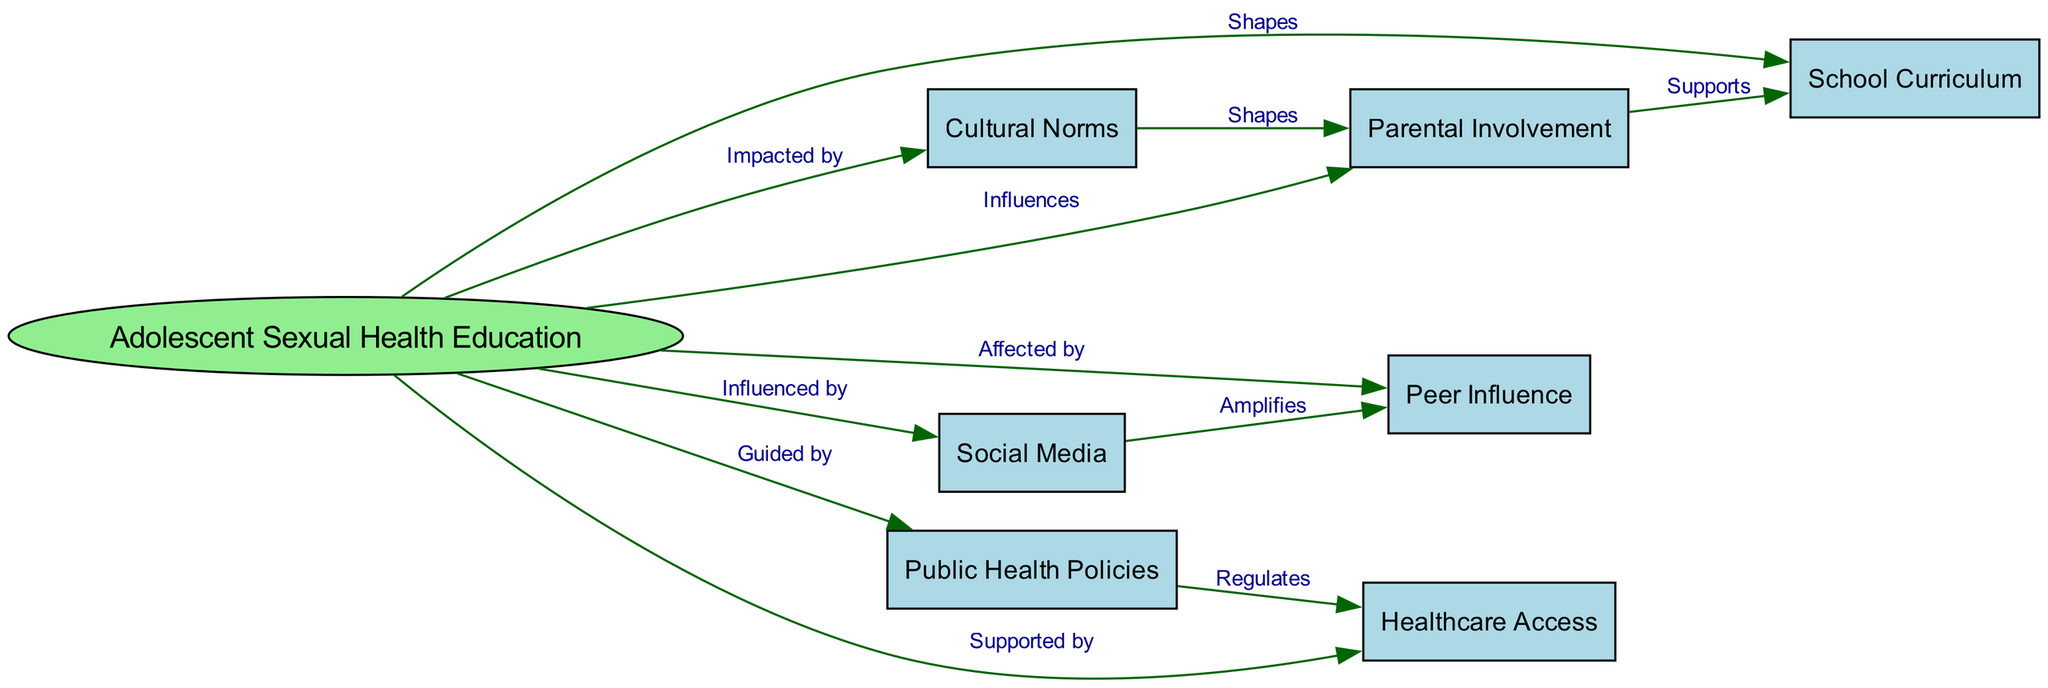What is the central topic of the concept map? The concept map has "Adolescent Sexual Health Education" at the center, which serves as the main focus from which all other elements are interconnected.
Answer: Adolescent Sexual Health Education How many nodes are in the diagram? The diagram contains a total of 8 nodes, each representing different factors affecting adolescent sexual health education.
Answer: 8 What type of relationship is shown between "Adolescent Sexual Health Education" and "School Curriculum"? The relationship is labeled as "Shapes," indicating that the school curriculum influences how adolescent sexual health education is structured and delivered.
Answer: Shapes Which factor is said to shape "Parental Involvement"? The diagram indicates that "Cultural Norms" shape parental involvement, suggesting that societal beliefs and values affect how parents engage in sexual health education.
Answer: Cultural Norms What is the relationship between "Public Health Policies" and "Healthcare Access"? The relationship is labeled as "Regulates," meaning that public health policies influence the availability and accessibility of healthcare services for adolescents.
Answer: Regulates Which node amplifies "Peer Influence"? The diagram indicates that "Social Media" amplifies peer influence, suggesting that online connections can enhance the effects of peer dynamics in sexual health education.
Answer: Social Media How does "Parental Involvement" interact with the "School Curriculum"? The relationship is labeled as "Supports," indicating that parental involvement plays a supportive role in the educational curriculum regarding sexual health for adolescents.
Answer: Supports How many edges are drawn from "Adolescent Sexual Health Education" to other nodes? There are 6 edges drawn from "Adolescent Sexual Health Education," connecting it to various influencing factors and support mechanisms.
Answer: 6 What are the factors that "Adolescent Sexual Health Education" is influenced by? The factors include "Parental Involvement," "Peer Influence," "Cultural Norms," "Social Media," and "Public Health Policies," indicating multiple sources of influence on the education topic.
Answer: Parental Involvement, Peer Influence, Cultural Norms, Social Media, Public Health Policies 